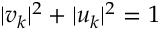Convert formula to latex. <formula><loc_0><loc_0><loc_500><loc_500>| v _ { k } | ^ { 2 } + | u _ { k } | ^ { 2 } = 1</formula> 